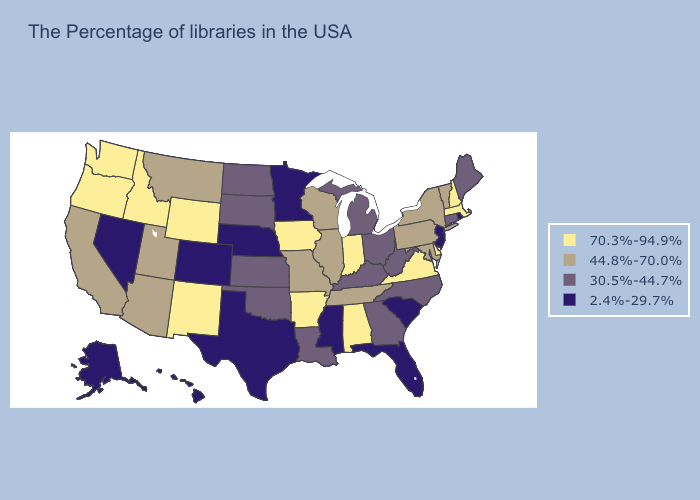Does the first symbol in the legend represent the smallest category?
Answer briefly. No. Name the states that have a value in the range 2.4%-29.7%?
Short answer required. Rhode Island, New Jersey, South Carolina, Florida, Mississippi, Minnesota, Nebraska, Texas, Colorado, Nevada, Alaska, Hawaii. Which states have the lowest value in the South?
Keep it brief. South Carolina, Florida, Mississippi, Texas. Does New Hampshire have a higher value than New Mexico?
Short answer required. No. Name the states that have a value in the range 44.8%-70.0%?
Answer briefly. Vermont, New York, Maryland, Pennsylvania, Tennessee, Wisconsin, Illinois, Missouri, Utah, Montana, Arizona, California. Which states hav the highest value in the Northeast?
Quick response, please. Massachusetts, New Hampshire. Which states have the lowest value in the USA?
Write a very short answer. Rhode Island, New Jersey, South Carolina, Florida, Mississippi, Minnesota, Nebraska, Texas, Colorado, Nevada, Alaska, Hawaii. Name the states that have a value in the range 70.3%-94.9%?
Short answer required. Massachusetts, New Hampshire, Delaware, Virginia, Indiana, Alabama, Arkansas, Iowa, Wyoming, New Mexico, Idaho, Washington, Oregon. Name the states that have a value in the range 44.8%-70.0%?
Quick response, please. Vermont, New York, Maryland, Pennsylvania, Tennessee, Wisconsin, Illinois, Missouri, Utah, Montana, Arizona, California. Name the states that have a value in the range 70.3%-94.9%?
Give a very brief answer. Massachusetts, New Hampshire, Delaware, Virginia, Indiana, Alabama, Arkansas, Iowa, Wyoming, New Mexico, Idaho, Washington, Oregon. What is the value of Arkansas?
Be succinct. 70.3%-94.9%. Does the map have missing data?
Be succinct. No. What is the highest value in the USA?
Answer briefly. 70.3%-94.9%. Name the states that have a value in the range 70.3%-94.9%?
Write a very short answer. Massachusetts, New Hampshire, Delaware, Virginia, Indiana, Alabama, Arkansas, Iowa, Wyoming, New Mexico, Idaho, Washington, Oregon. Does Michigan have the highest value in the MidWest?
Quick response, please. No. 